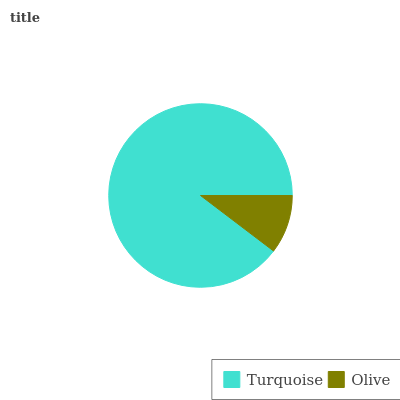Is Olive the minimum?
Answer yes or no. Yes. Is Turquoise the maximum?
Answer yes or no. Yes. Is Olive the maximum?
Answer yes or no. No. Is Turquoise greater than Olive?
Answer yes or no. Yes. Is Olive less than Turquoise?
Answer yes or no. Yes. Is Olive greater than Turquoise?
Answer yes or no. No. Is Turquoise less than Olive?
Answer yes or no. No. Is Turquoise the high median?
Answer yes or no. Yes. Is Olive the low median?
Answer yes or no. Yes. Is Olive the high median?
Answer yes or no. No. Is Turquoise the low median?
Answer yes or no. No. 